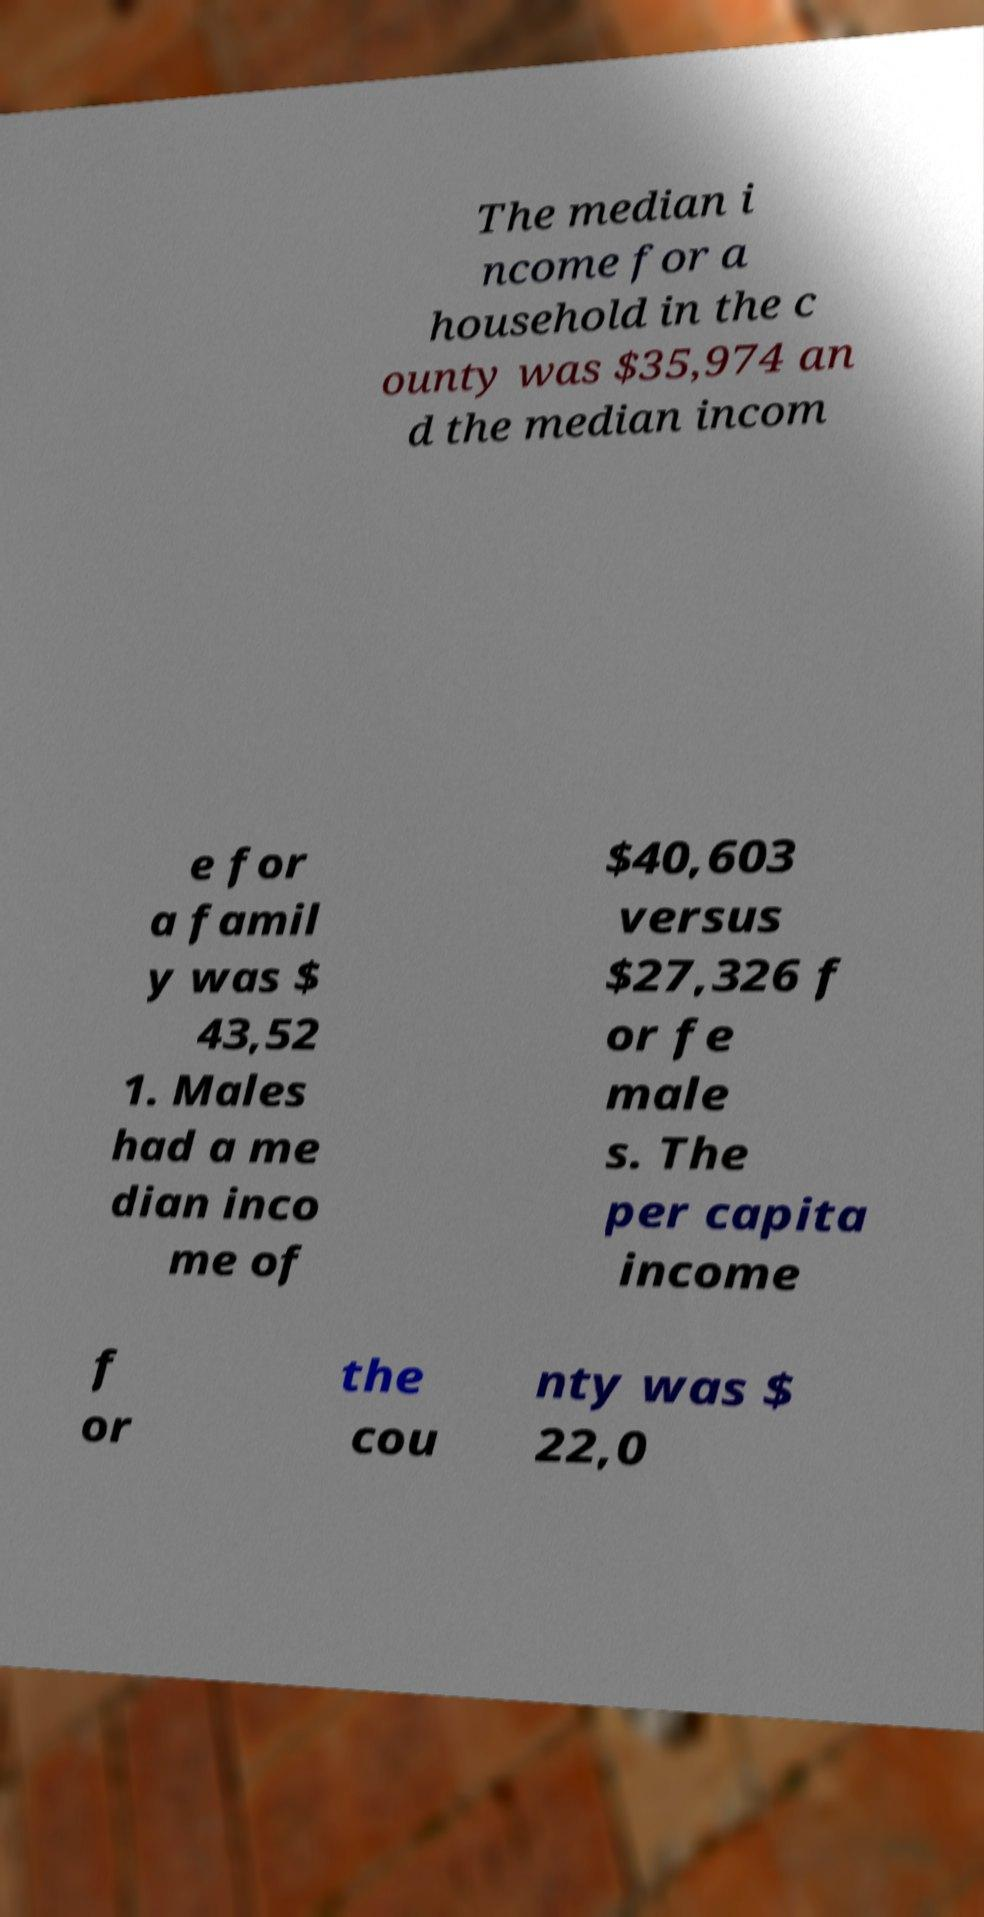Please read and relay the text visible in this image. What does it say? The median i ncome for a household in the c ounty was $35,974 an d the median incom e for a famil y was $ 43,52 1. Males had a me dian inco me of $40,603 versus $27,326 f or fe male s. The per capita income f or the cou nty was $ 22,0 